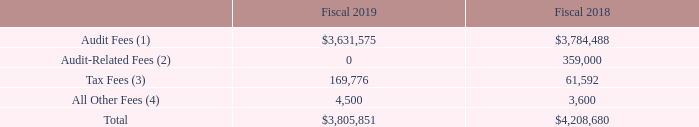Audit and Non-Audit Fees
The following table presents fees billed for professional audit services rendered by PricewaterhouseCoopers LLP for the audit of the Company’s annual financial statements for the years ended June 29, 2019 and June 30, 2018 respectively, and fees billed for other services rendered by PricewaterhouseCoopers LLP and during those periods.
(1) Audit Fees are related to professional services rendered in connection with the audit of the Company’s annual financial statements, the audit of internal control over financial reporting in accordance with Section 404 of the Sarbanes-Oxley Act of 2002, reviews of financial statements included in the Company’s Quarterly Reports on Form 10-Q, and audit services provided in connection with other statutory and regulatory filings. Audit Fees in fiscal 2019 include fees for services performed by PricewaterhouseCoopers LLP in connection with the acquisitions of RPC Photonics, Inc. (“RPC”) and 3Z Telecom, Inc. (“3Z”). Audit Fees in fiscal 2018 include fees for the acquisitions of the AvComm and Wireless businesses of Cobham plc (“AW”) and Trilithic Inc. (“Trilithic”).
(2) Audit-Related Fees are related to due diligence services for our acquisition activities incurred in fiscal 2018.
(3) Tax Fees for fiscal 2019 and 2018 include professional services rendered in connection with transfer pricing consulting, tax audits, planning services and other tax consulting.
(4) All Other Fees are related to certain software subscription fees.
For fiscal year 2019, the Audit Committee considered whether audit-related services and services other than audit-related services provided by PricewaterhouseCoopers LLP are compatible with maintaining the independence of PricewaterhouseCoopers LLP and concluded that the independence of PricewaterhouseCoopers LLP was maintained.
How much were Audit fees in 2019? $3,631,575. How much were Tax Fees in 2019? 169,776. What is the change in Audit Fees as a percentage between 2018 and 2019?
Answer scale should be: percent. (3,631,575-3,784,488)/3,784,488
Answer: -4.04. What is the change in All Other Fees as a percentage between 2018 and 2019?
Answer scale should be: percent. (4,500-3,600)/3,600
Answer: 25. What is the total of Tax Fees and All Other Fees in 2019? 169,776+4,500
Answer: 174276. What are Audit-Related fees related to? Audit-related fees are related to due diligence services for our acquisition activities incurred in fiscal 2018. 